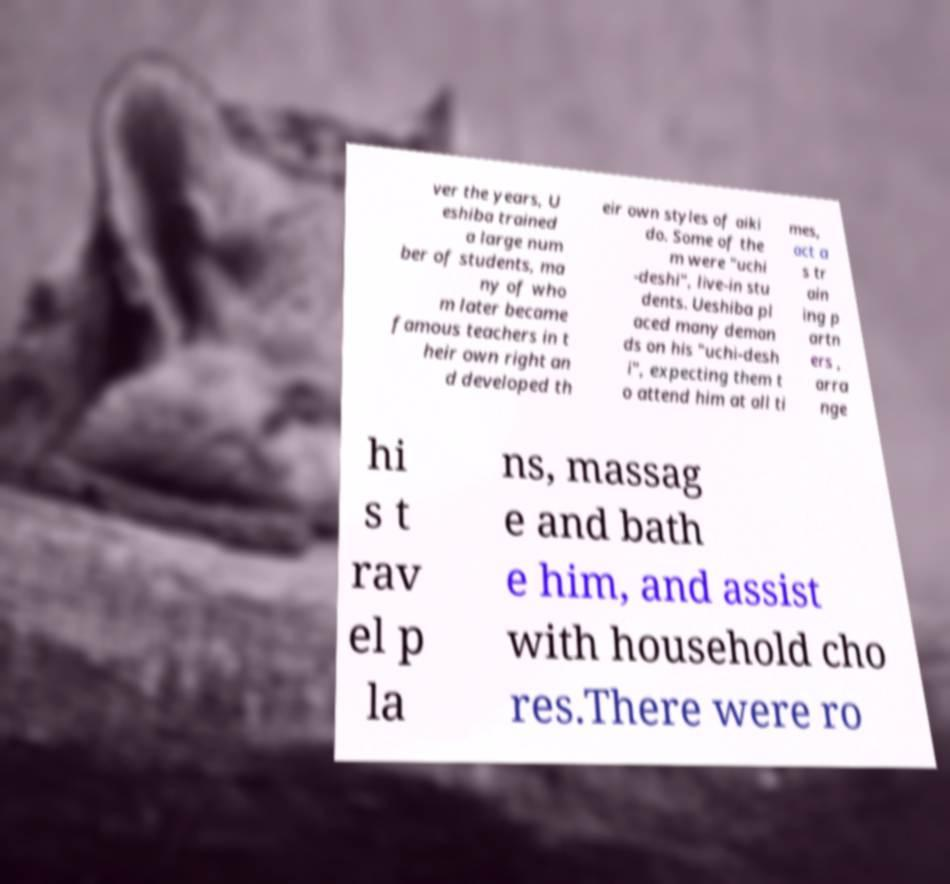What messages or text are displayed in this image? I need them in a readable, typed format. ver the years, U eshiba trained a large num ber of students, ma ny of who m later became famous teachers in t heir own right an d developed th eir own styles of aiki do. Some of the m were "uchi -deshi", live-in stu dents. Ueshiba pl aced many deman ds on his "uchi-desh i", expecting them t o attend him at all ti mes, act a s tr ain ing p artn ers , arra nge hi s t rav el p la ns, massag e and bath e him, and assist with household cho res.There were ro 